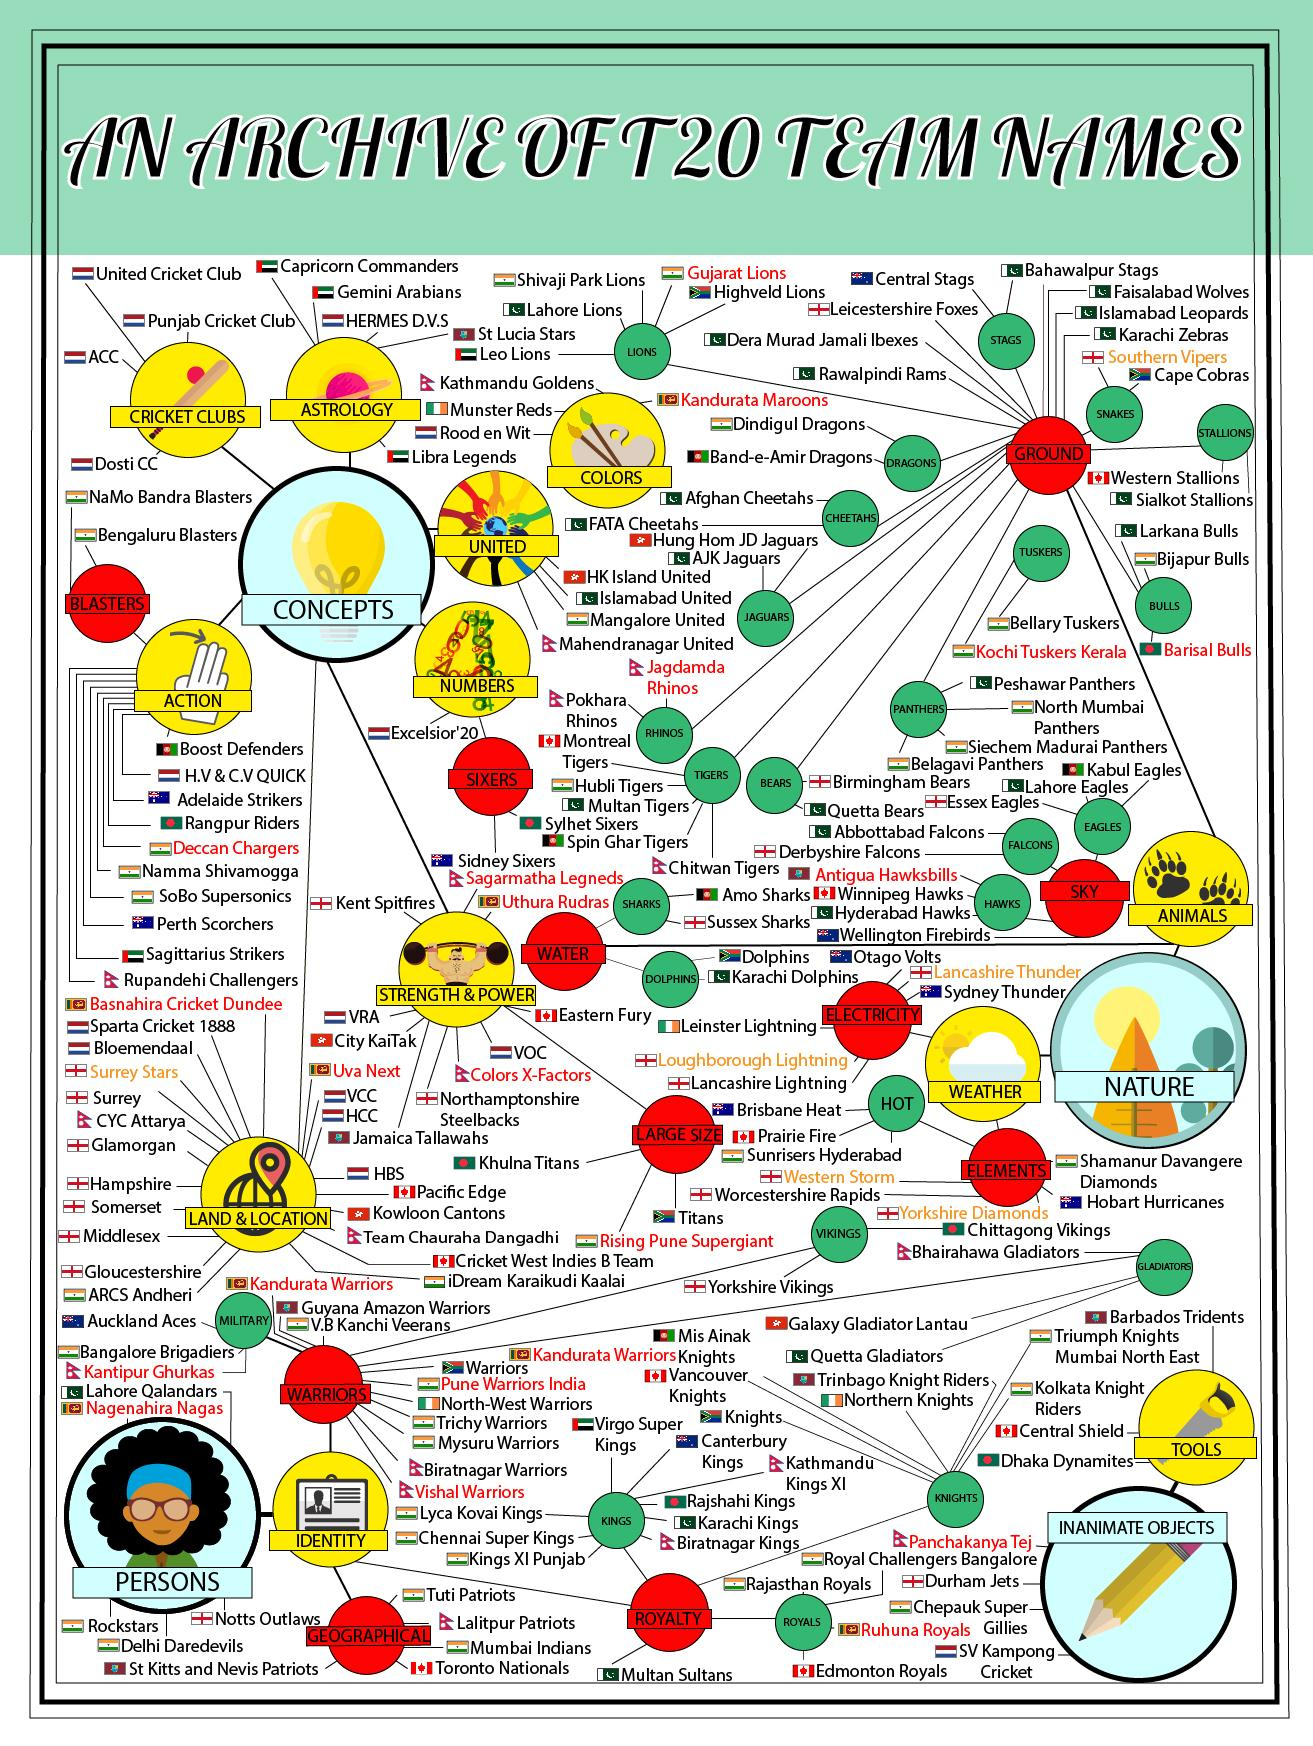Mention a couple of crucial points in this snapshot. The following are team names that are related to snakes: Cape cobras and southern vipers. There are two teams named Rajasthan Royals and Edmonton Royals. There are three teams whose names end with the word "Bulls": Larkana Bulls, Bijapur Bulls, and Barisal Bulls. There are teams that have names ending with "Dragons." These teams include Dindigul Dragons, Band-e Amir Dragons, and other teams whose names end with the suffix "Dragons. There are three team names that contain the word "Gladiator. 